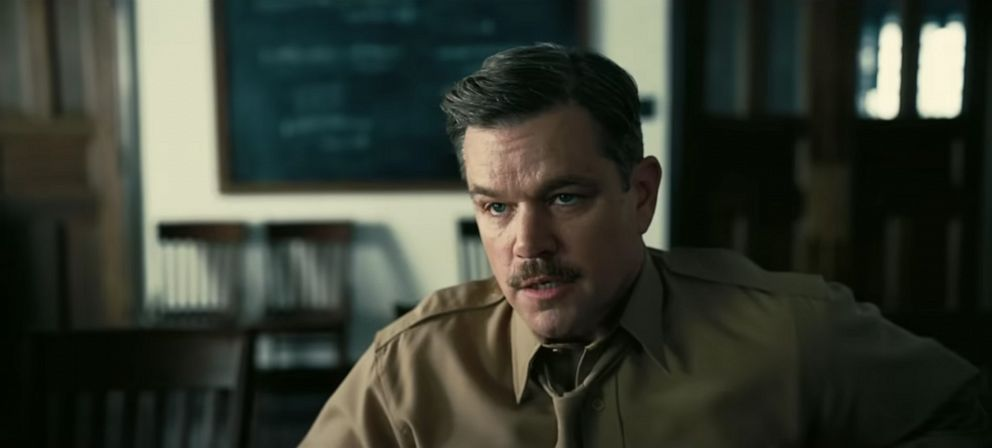What's happening in the scene? In this image, an individual is seated on a wooden chair in a room resembling an academic setting. The background features a blackboard filled with chalk-written equations, reinforcing the intellectual atmosphere. Clad in a beige shirt, the person exudes a professional yet casual air. Their face, adorned with a mustache, exudes maturity and thoughtfulness, while their serious expression suggests deep contemplation or engagement in a meaningful conversation. This scene could depict a character involved in an academic discussion or reflecting on a complex problem. 